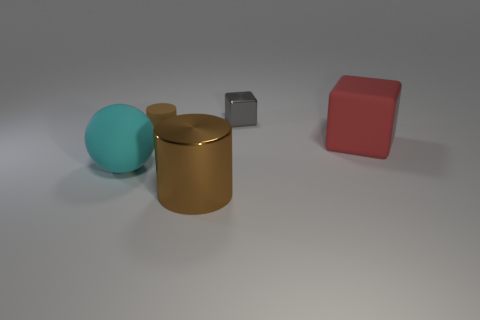Add 4 red blocks. How many objects exist? 9 Subtract all spheres. How many objects are left? 4 Add 1 cyan spheres. How many cyan spheres are left? 2 Add 5 small metal cubes. How many small metal cubes exist? 6 Subtract 0 green cubes. How many objects are left? 5 Subtract all tiny cylinders. Subtract all metallic cylinders. How many objects are left? 3 